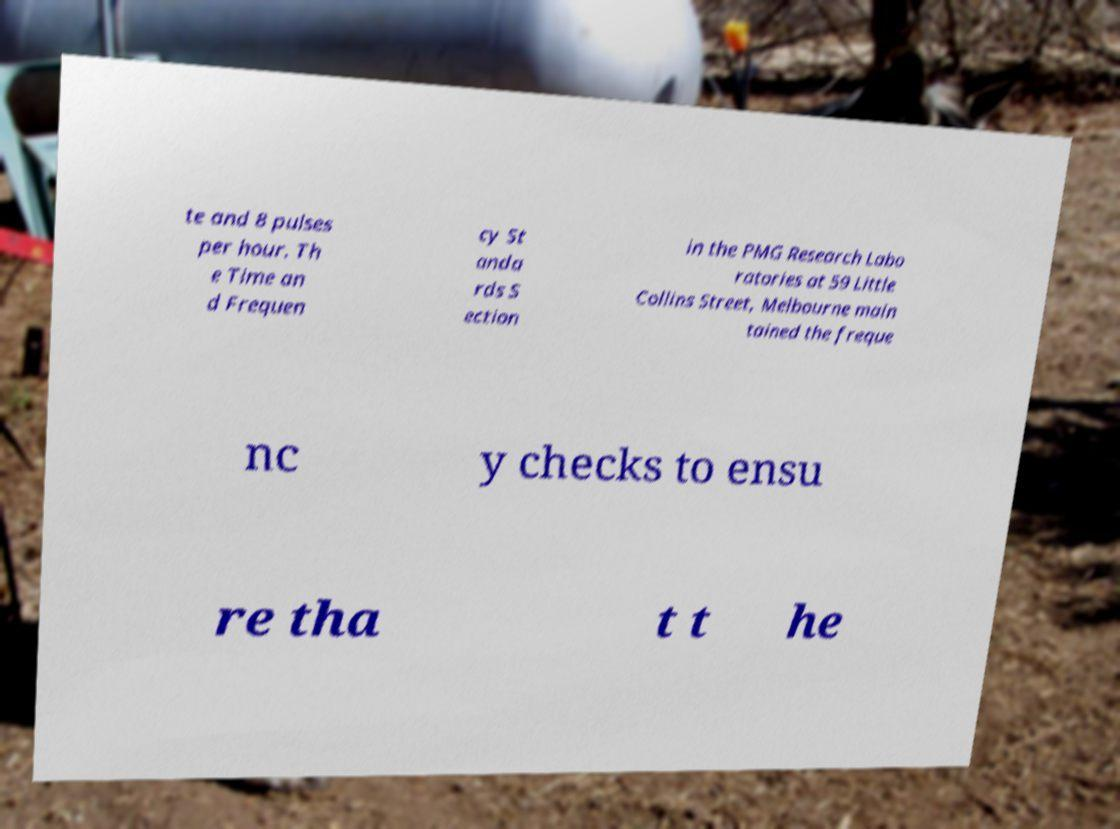There's text embedded in this image that I need extracted. Can you transcribe it verbatim? te and 8 pulses per hour. Th e Time an d Frequen cy St anda rds S ection in the PMG Research Labo ratories at 59 Little Collins Street, Melbourne main tained the freque nc y checks to ensu re tha t t he 